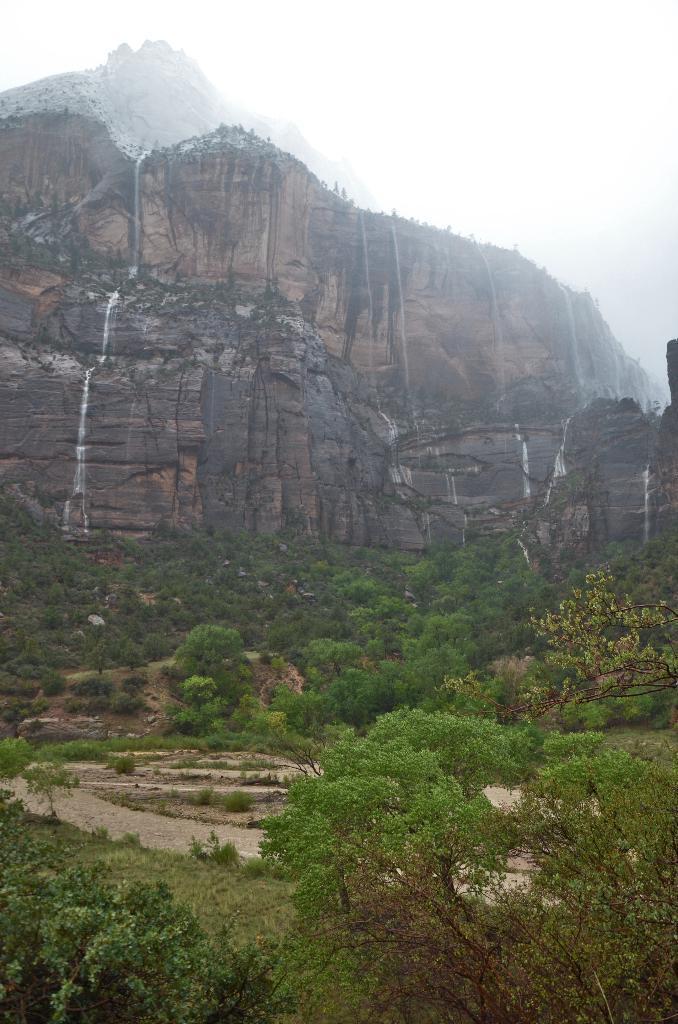How would you summarize this image in a sentence or two? In this image, we can see a beautiful view where there are number of trees at the bottom and there is also a hill and it is almost foggy. 